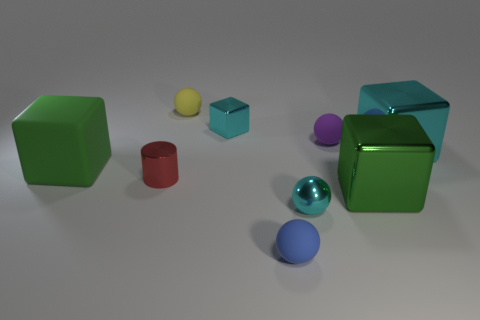Subtract all small metallic balls. How many balls are left? 3 Subtract all cyan balls. How many balls are left? 3 Subtract all blocks. How many objects are left? 5 Subtract all gray blocks. How many blue spheres are left? 1 Subtract all big green shiny cylinders. Subtract all tiny yellow matte balls. How many objects are left? 8 Add 9 purple spheres. How many purple spheres are left? 10 Add 6 metallic blocks. How many metallic blocks exist? 9 Subtract 0 yellow cylinders. How many objects are left? 9 Subtract 1 cylinders. How many cylinders are left? 0 Subtract all green balls. Subtract all red cylinders. How many balls are left? 4 